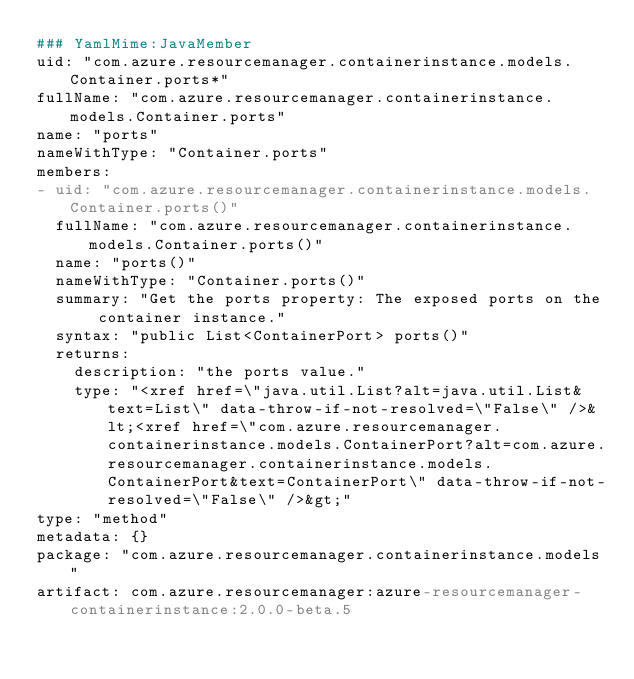Convert code to text. <code><loc_0><loc_0><loc_500><loc_500><_YAML_>### YamlMime:JavaMember
uid: "com.azure.resourcemanager.containerinstance.models.Container.ports*"
fullName: "com.azure.resourcemanager.containerinstance.models.Container.ports"
name: "ports"
nameWithType: "Container.ports"
members:
- uid: "com.azure.resourcemanager.containerinstance.models.Container.ports()"
  fullName: "com.azure.resourcemanager.containerinstance.models.Container.ports()"
  name: "ports()"
  nameWithType: "Container.ports()"
  summary: "Get the ports property: The exposed ports on the container instance."
  syntax: "public List<ContainerPort> ports()"
  returns:
    description: "the ports value."
    type: "<xref href=\"java.util.List?alt=java.util.List&text=List\" data-throw-if-not-resolved=\"False\" />&lt;<xref href=\"com.azure.resourcemanager.containerinstance.models.ContainerPort?alt=com.azure.resourcemanager.containerinstance.models.ContainerPort&text=ContainerPort\" data-throw-if-not-resolved=\"False\" />&gt;"
type: "method"
metadata: {}
package: "com.azure.resourcemanager.containerinstance.models"
artifact: com.azure.resourcemanager:azure-resourcemanager-containerinstance:2.0.0-beta.5
</code> 